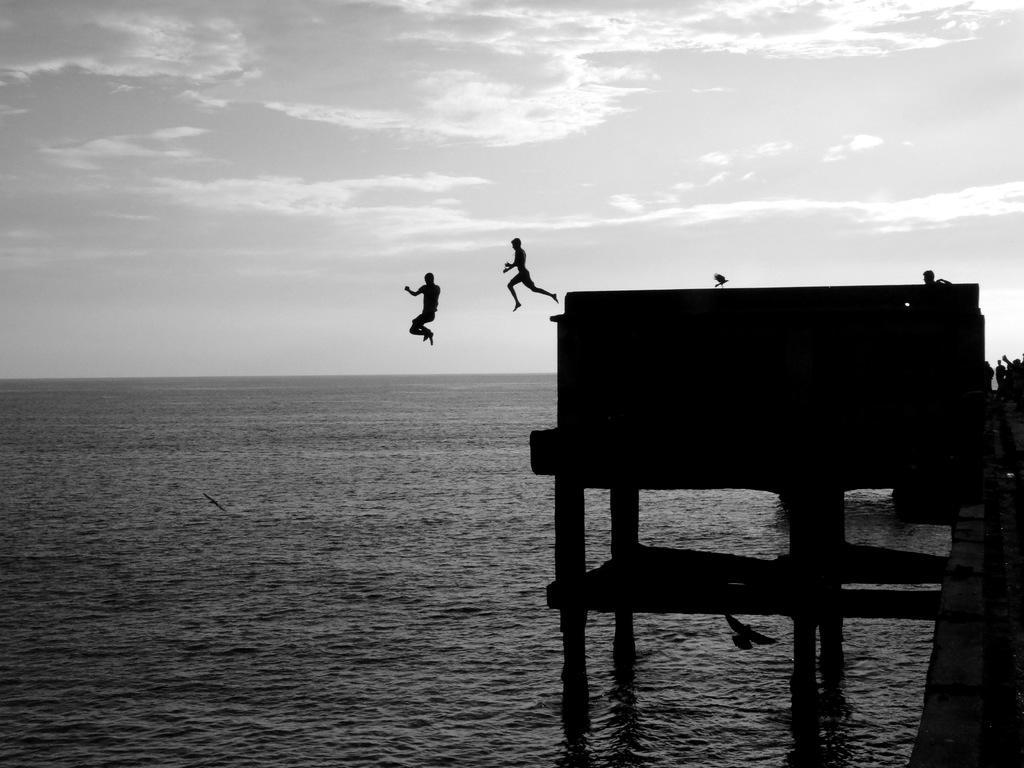Could you give a brief overview of what you see in this image? This picture shows couple of men jumping into the water from the bridge and we see a bird. 